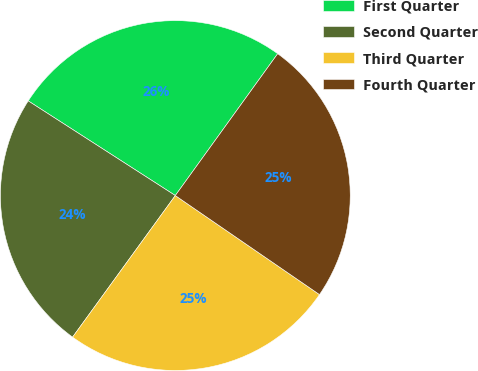Convert chart to OTSL. <chart><loc_0><loc_0><loc_500><loc_500><pie_chart><fcel>First Quarter<fcel>Second Quarter<fcel>Third Quarter<fcel>Fourth Quarter<nl><fcel>25.85%<fcel>24.11%<fcel>25.41%<fcel>24.63%<nl></chart> 